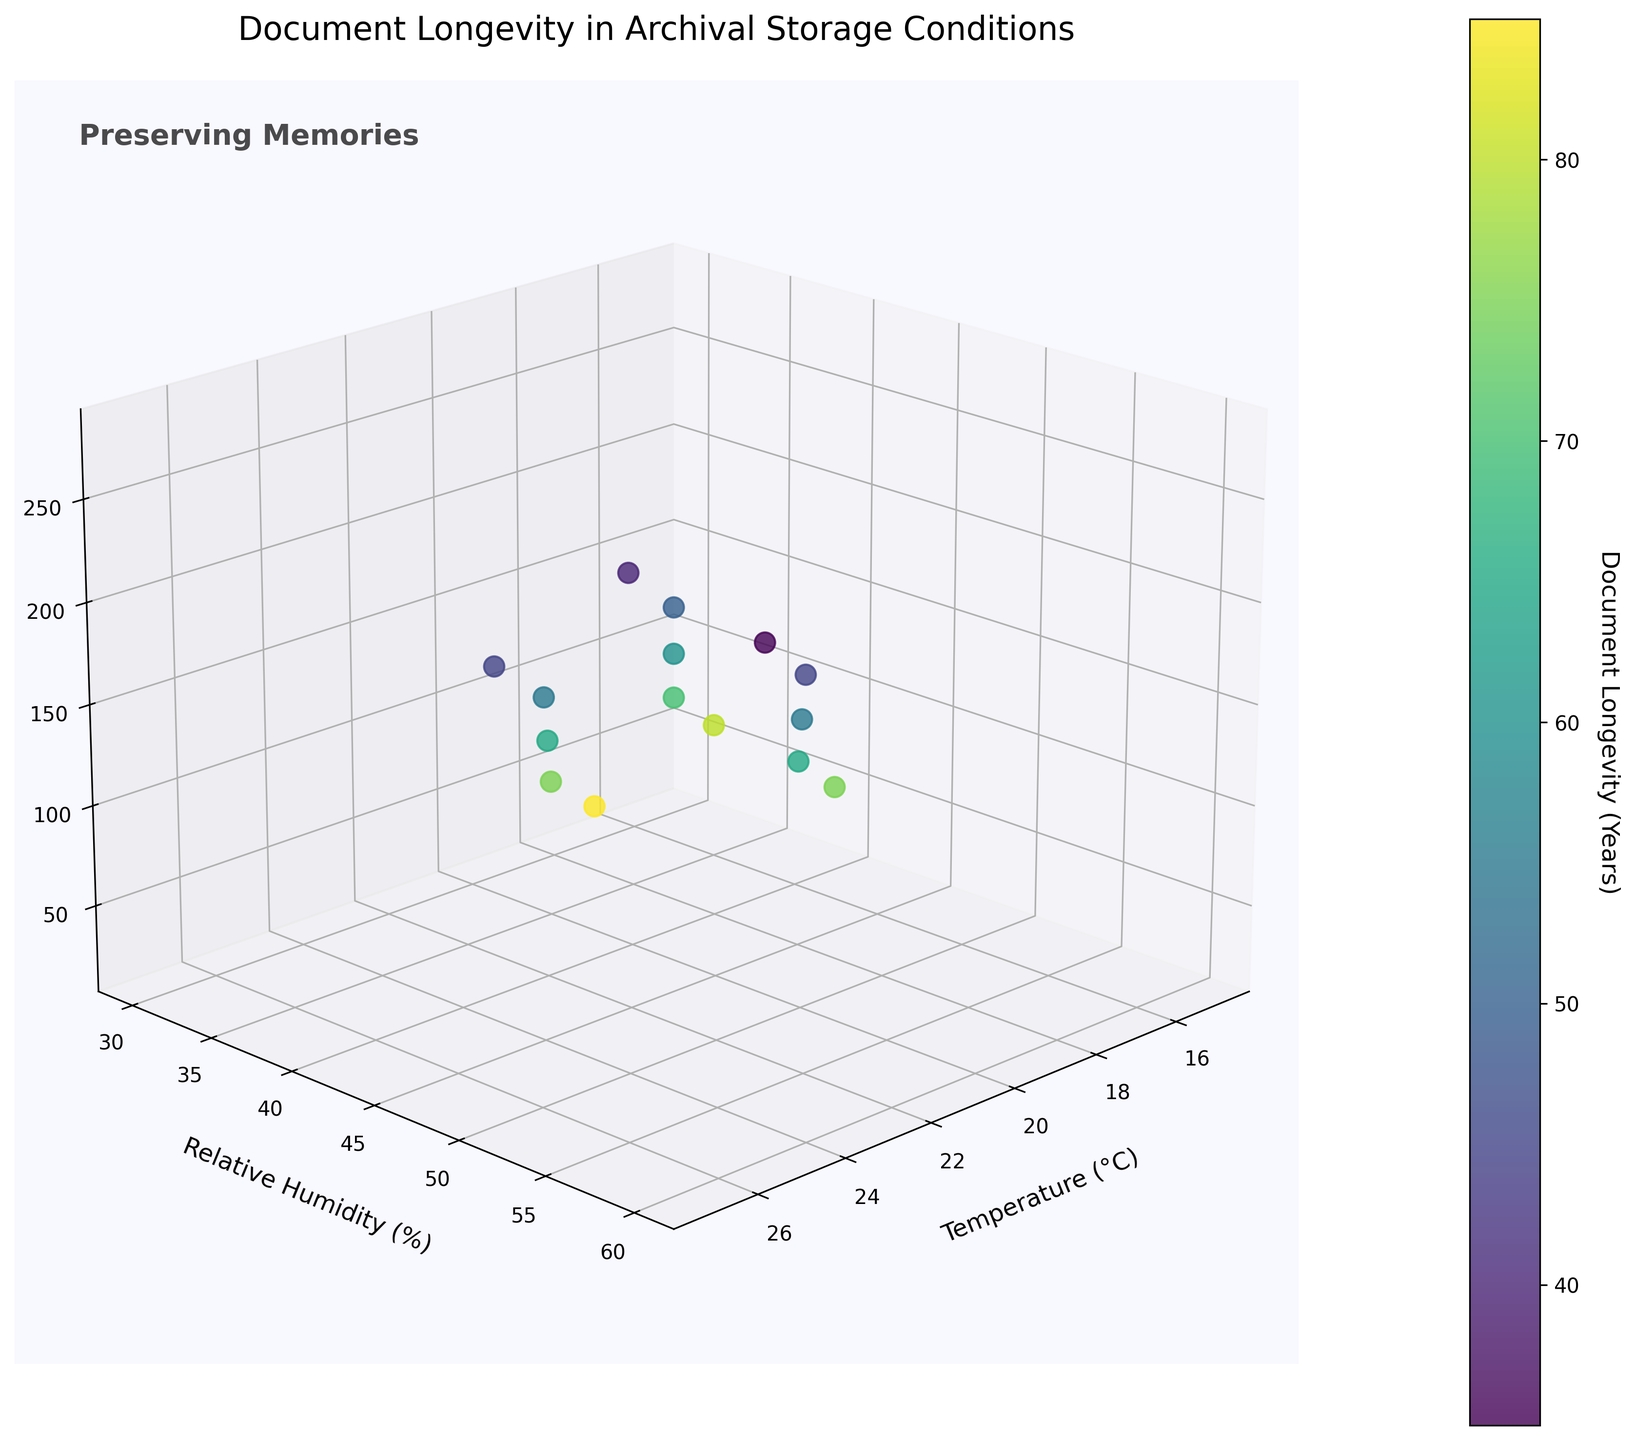What is the title of the 3D plot? The title of the 3D plot is indicated at the top of the plot. It reads "Document Longevity in Archival Storage Conditions".
Answer: Document Longevity in Archival Storage Conditions What does the color bar represent in the figure? The color bar adjacent to the plot shows the range of colors corresponding to different values of "Document Longevity (Years)".
Answer: Document Longevity (Years) How many variables are plotted in the 3D space? Three variables are plotted in the 3D space: Temperature (°C), Relative Humidity (%), and Light Exposure (Lux). This can be inferred from the x, y, and z-axis labels.
Answer: Three Which axis represents 'Relative Humidity'? The y-axis represents 'Relative Humidity', as it is labeled accordingly on the plot.
Answer: y-axis Which data point has the highest document longevity? The highest document longevity is represented by the data point with the lightest color. The point with the highest longevity (85 years) corresponds to Temperature 17°C, Relative Humidity 30%, and Light Exposure 25 Lux.
Answer: 17°C, 30%, 25 Lux Among the variables Temperature, Humidity, and Light Exposure, which one tends to have values in the lowest range when document longevity is the highest? The data point with the highest document longevity shows that the Light Exposure has the lowest value among the three. This indicates that lower Light Exposure tends to be associated with higher document longevity.
Answer: Light Exposure What is the document longevity when the Temperature is 22°C, Relative Humidity is 40%, and Light Exposure is 125 Lux? By locating the data point where Temperature is 22°C, Relative Humidity is 40%, and Light Exposure is 125 Lux, we find that the document longevity is 65 years.
Answer: 65 years If you increase both Temperature and Light Exposure, what happens to document longevity? By observing the trend in the plot, an increase in both Temperature and Light Exposure generally results in a decrease in document longevity. This can be inferred from the gradient of colors showing shorter longevity.
Answer: Decreases Identify the data point with the lowest value of Relative Humidity. What is the corresponding document longevity? The data point with the lowest value of Relative Humidity (30%) corresponds to a document longevity of 85 years.
Answer: 85 years What is the range of Light Exposure values represented in the plot? The Light Exposure values range from the minimum value of 25 Lux to the maximum value of 275 Lux in the plot.
Answer: 25 Lux to 275 Lux 